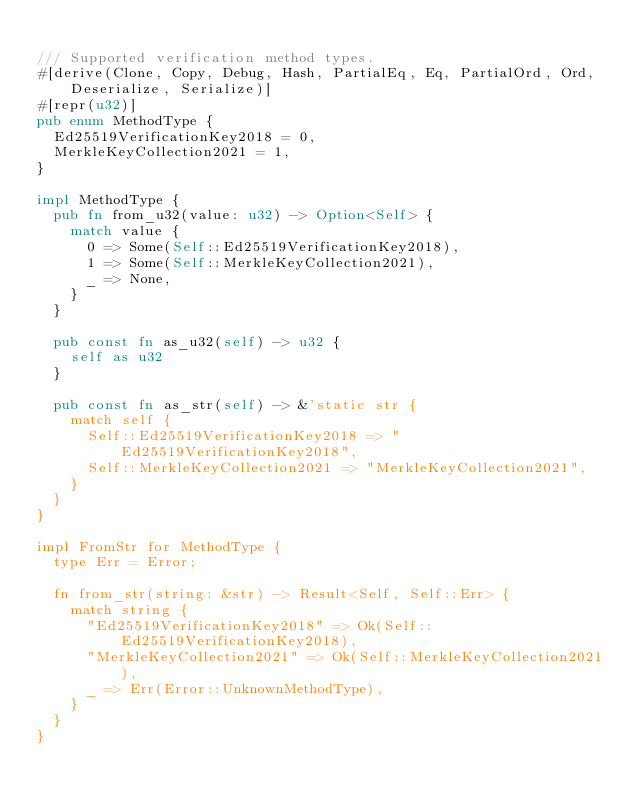<code> <loc_0><loc_0><loc_500><loc_500><_Rust_>
/// Supported verification method types.
#[derive(Clone, Copy, Debug, Hash, PartialEq, Eq, PartialOrd, Ord, Deserialize, Serialize)]
#[repr(u32)]
pub enum MethodType {
  Ed25519VerificationKey2018 = 0,
  MerkleKeyCollection2021 = 1,
}

impl MethodType {
  pub fn from_u32(value: u32) -> Option<Self> {
    match value {
      0 => Some(Self::Ed25519VerificationKey2018),
      1 => Some(Self::MerkleKeyCollection2021),
      _ => None,
    }
  }

  pub const fn as_u32(self) -> u32 {
    self as u32
  }

  pub const fn as_str(self) -> &'static str {
    match self {
      Self::Ed25519VerificationKey2018 => "Ed25519VerificationKey2018",
      Self::MerkleKeyCollection2021 => "MerkleKeyCollection2021",
    }
  }
}

impl FromStr for MethodType {
  type Err = Error;

  fn from_str(string: &str) -> Result<Self, Self::Err> {
    match string {
      "Ed25519VerificationKey2018" => Ok(Self::Ed25519VerificationKey2018),
      "MerkleKeyCollection2021" => Ok(Self::MerkleKeyCollection2021),
      _ => Err(Error::UnknownMethodType),
    }
  }
}
</code> 